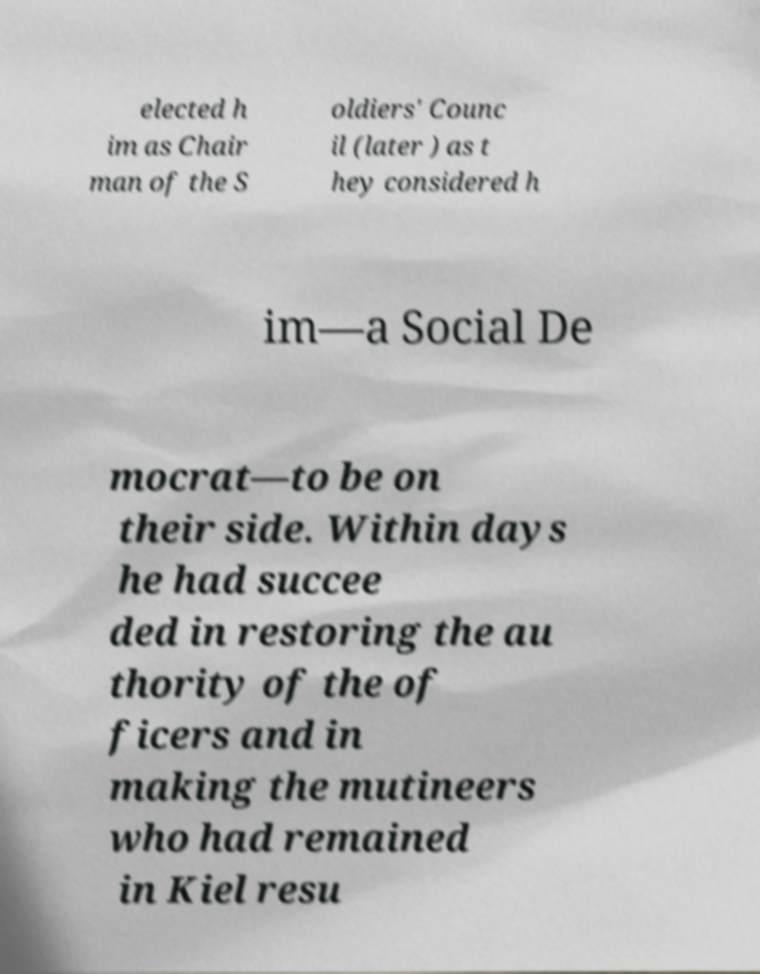There's text embedded in this image that I need extracted. Can you transcribe it verbatim? elected h im as Chair man of the S oldiers' Counc il (later ) as t hey considered h im—a Social De mocrat—to be on their side. Within days he had succee ded in restoring the au thority of the of ficers and in making the mutineers who had remained in Kiel resu 